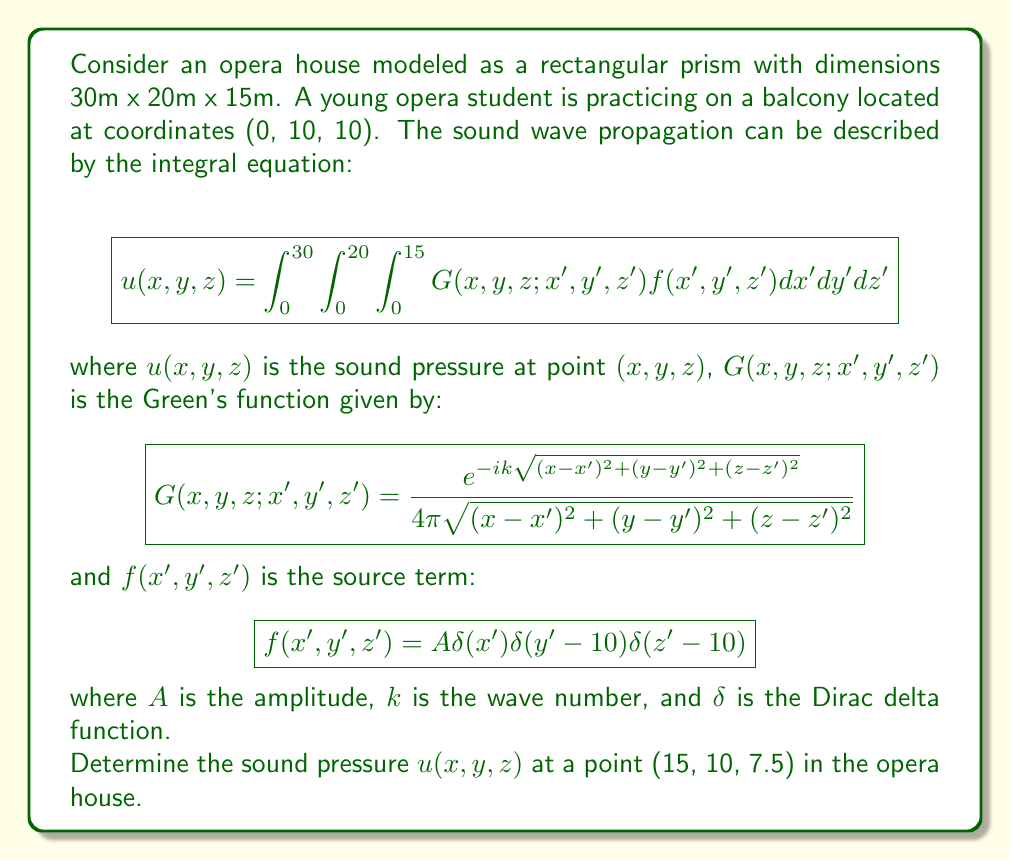Help me with this question. Let's approach this problem step-by-step:

1) First, we need to substitute the given Green's function and source term into the integral equation:

   $$u(15,10,7.5) = \int_0^{30}\int_0^{20}\int_0^{15} \frac{e^{-ik\sqrt{(15-x')^2+(10-y')^2+(7.5-z')^2}}}{4\pi\sqrt{(15-x')^2+(10-y')^2+(7.5-z')^2}} A\delta(x')\delta(y'-10)\delta(z'-10)dx'dy'dz'$$

2) The Dirac delta functions in the source term simplify our integral significantly. They effectively evaluate the integrand at the point (0, 10, 10):

   $$u(15,10,7.5) = A \frac{e^{-ik\sqrt{15^2+0^2+(-2.5)^2}}}{4\pi\sqrt{15^2+0^2+(-2.5)^2}}$$

3) Simplify the expression inside the square root:

   $$u(15,10,7.5) = A \frac{e^{-ik\sqrt{225+6.25}}}{4\pi\sqrt{225+6.25}} = A \frac{e^{-ik\sqrt{231.25}}}{4\pi\sqrt{231.25}}$$

4) Simplify further:

   $$u(15,10,7.5) = A \frac{e^{-ik15.21}}{4\pi(15.21)}$$

5) This is our final expression for the sound pressure at the point (15, 10, 7.5). The actual value would depend on the amplitude A and the wave number k, which are not specified in the problem.
Answer: $u(15,10,7.5) = A \frac{e^{-ik15.21}}{4\pi(15.21)}$ 